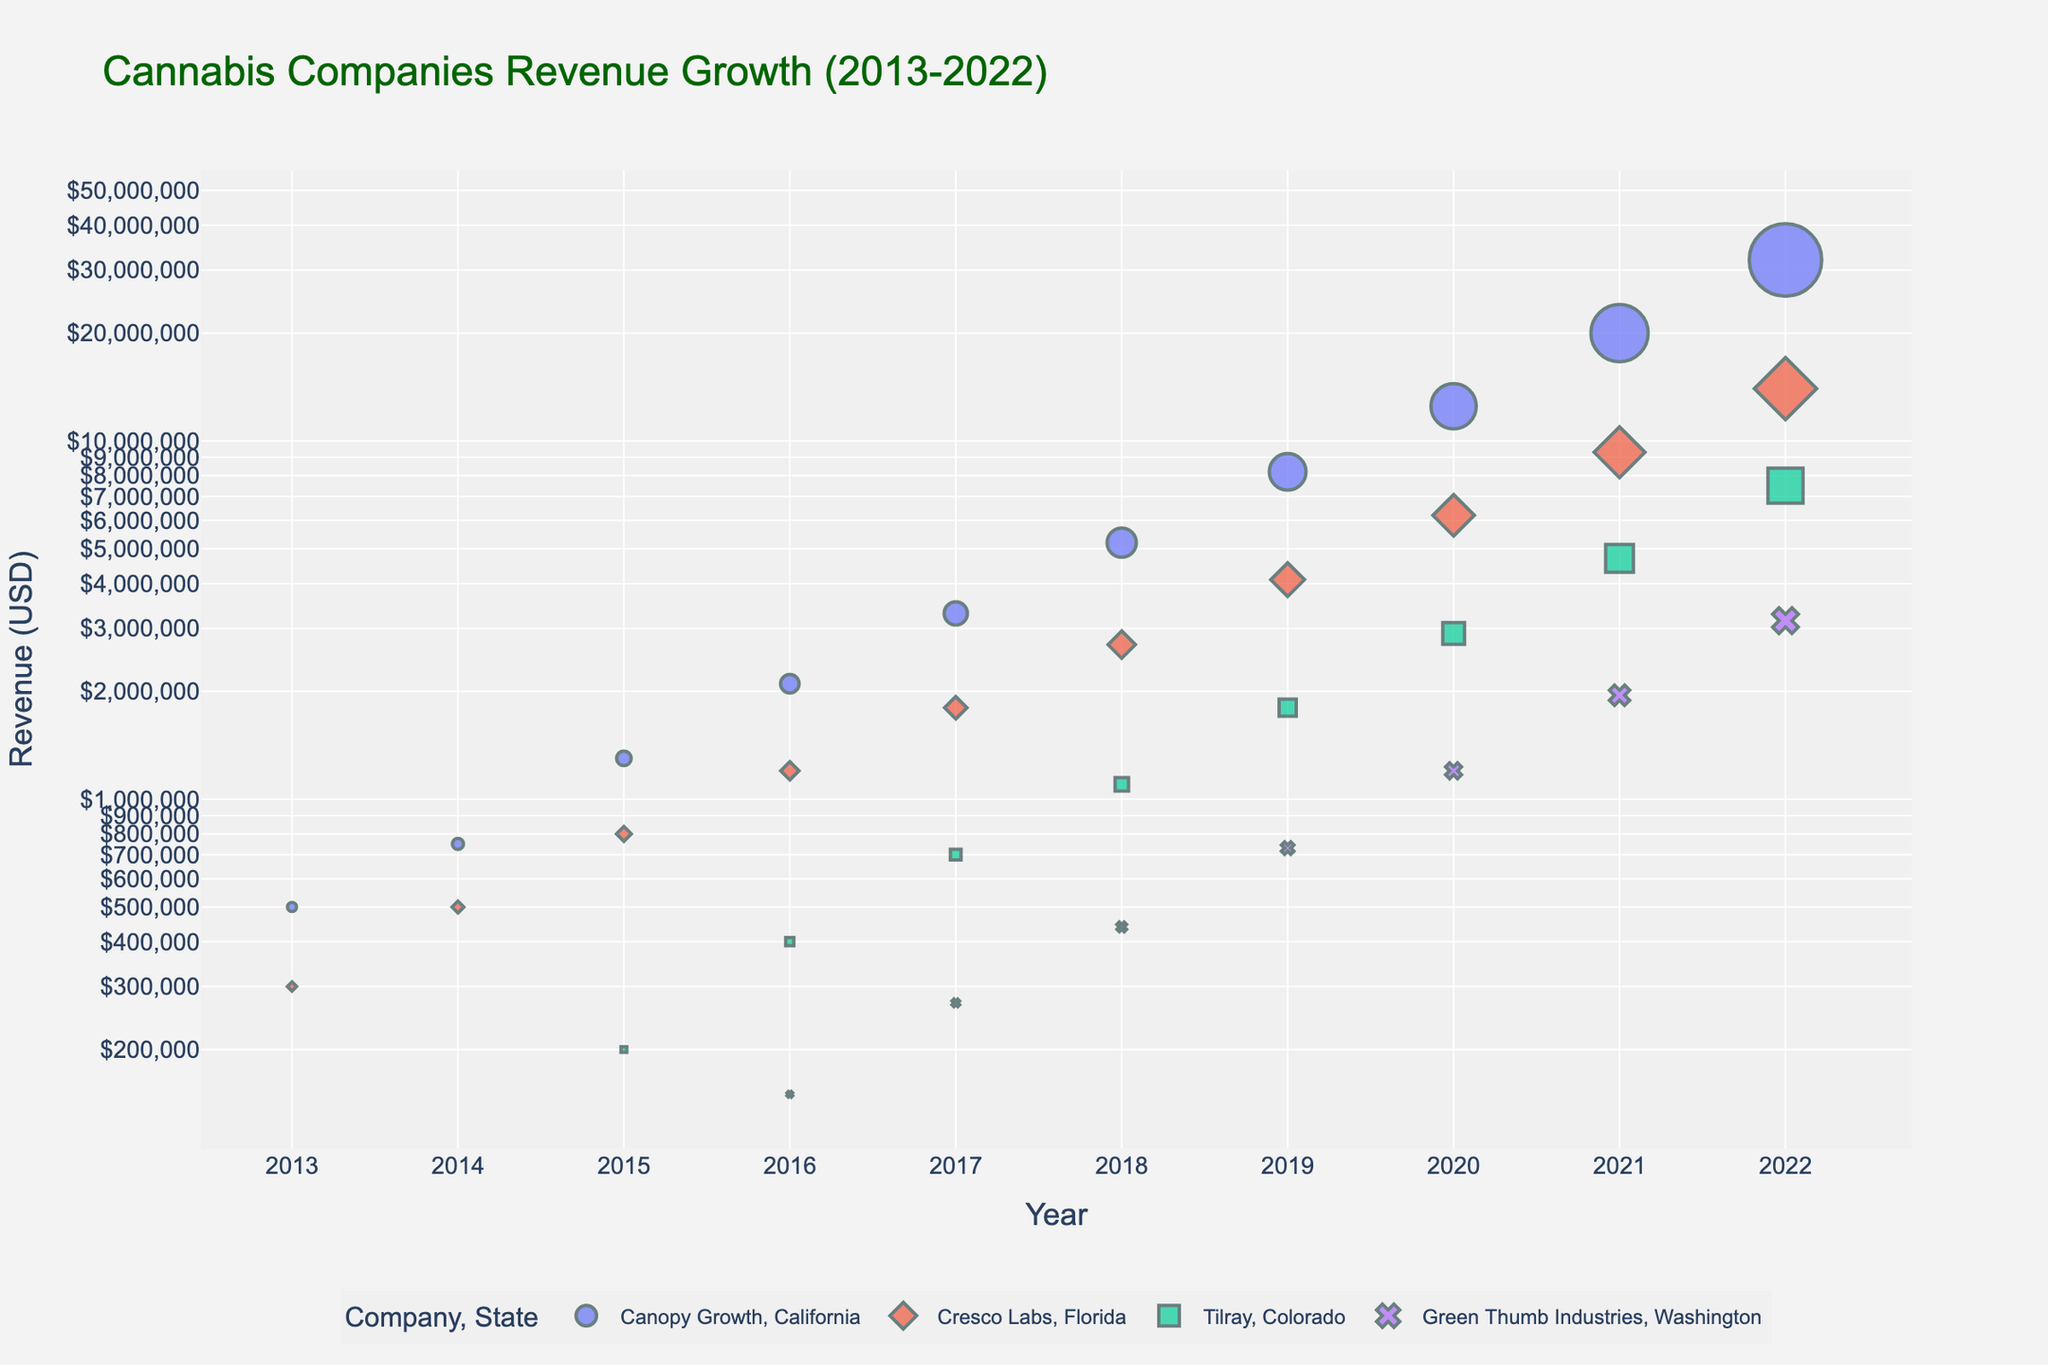What is the title of the plot? The title is usually located at the top of the figure. By looking for a large and prominently placed text, you can determine that the title of the plot is "Cannabis Companies Revenue Growth (2013-2022)".
Answer: Cannabis Companies Revenue Growth (2013-2022) What are the axes labels on the scatter plot? The x-axis is expected to show the years, and the y-axis should represent the revenue. We can identify them based on their positions: The x-axis is labeled "Year," and the y-axis is labeled "Revenue (USD)".
Answer: Year, Revenue (USD) Which company had the highest revenue in 2022? You can identify the highest revenue in 2022 by looking at the data points for 2022 and finding the one with the highest y-axis value. Based on this, Canopy Growth in California had the highest revenue.
Answer: Canopy Growth How does the revenue of Cresco Labs in Florida compare from 2013 to 2022? We need to locate the data points for Cresco Labs in Florida and compare the y-axis values from 2013 to 2022. The revenue increased from 300,000 USD in 2013 to 14,000,000 USD in 2022. This indicates substantial growth.
Answer: Increased significantly Which company had the fastest growth in revenue over the period shown? To determine the fastest growth, compare the slopes of the lines connecting data points of each company. Canopy Growth in California demonstrates the steepest curve, indicating the fastest growth rate.
Answer: Canopy Growth What is the revenue difference for Tilray in Colorado between 2015 and 2022? Locate the revenue values for Tilray in Colorado for 2015 and 2022. Subtract the value in 2015 (200,000 USD) from the value in 2022 (7,500,000 USD). The difference is 7,300,000 USD.
Answer: 7,300,000 USD What patterns do you observe in the revenue growth of Green Thumb Industries in Washington from 2016-2022? By analyzing the points for Green Thumb Industries in Washington, you can see that the revenue growth appears steady, with gradual increases each year, indicating consistent growth.
Answer: Steady, consistent growth How does the revenue trajectory of Canopy Growth in California compare to that of Green Thumb Industries in Washington? Compare the shapes of the curves for both companies from 2016-2022. Canopy Growth has a sharper upward curve indicating faster growth, while Green Thumb Industries shows steady and more gradual growth.
Answer: Faster growth for Canopy Growth, steady growth for Green Thumb In which year did Canopy Growth in California first surpass a revenue of 5 million USD? Inspect the points for Canopy Growth in California and find the year where the y-axis value first exceeds 5 million USD. This occurs in 2018.
Answer: 2018 